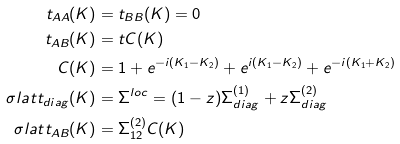<formula> <loc_0><loc_0><loc_500><loc_500>t _ { A A } ( K ) & = t _ { B B } ( K ) = 0 \\ t _ { A B } ( K ) & = t C ( K ) \\ C ( K ) & = 1 + e ^ { - i ( K _ { 1 } - K _ { 2 } ) } + e ^ { i ( K _ { 1 } - K _ { 2 } ) } + e ^ { - i ( K _ { 1 } + K _ { 2 } ) } \\ \sigma l a t t _ { d i a g } ( K ) & = \Sigma ^ { l o c } = ( 1 - z ) \Sigma ^ { ( 1 ) } _ { d i a g } + z \Sigma ^ { ( 2 ) } _ { d i a g } \\ \sigma l a t t _ { A B } ( K ) & = \Sigma ^ { ( 2 ) } _ { 1 2 } C ( K )</formula> 